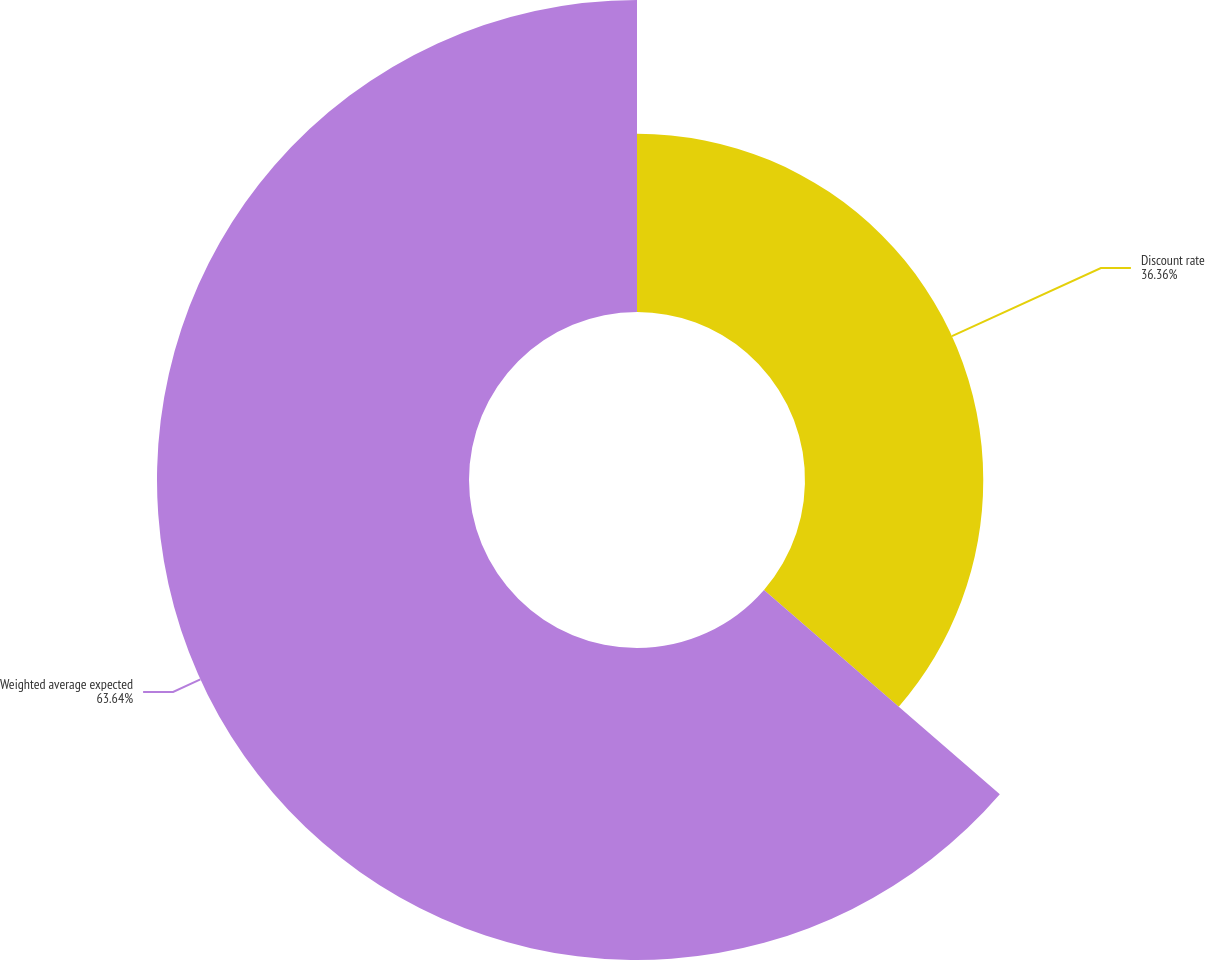Convert chart to OTSL. <chart><loc_0><loc_0><loc_500><loc_500><pie_chart><fcel>Discount rate<fcel>Weighted average expected<nl><fcel>36.36%<fcel>63.64%<nl></chart> 